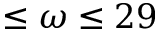<formula> <loc_0><loc_0><loc_500><loc_500>\leq \omega \leq 2 9</formula> 